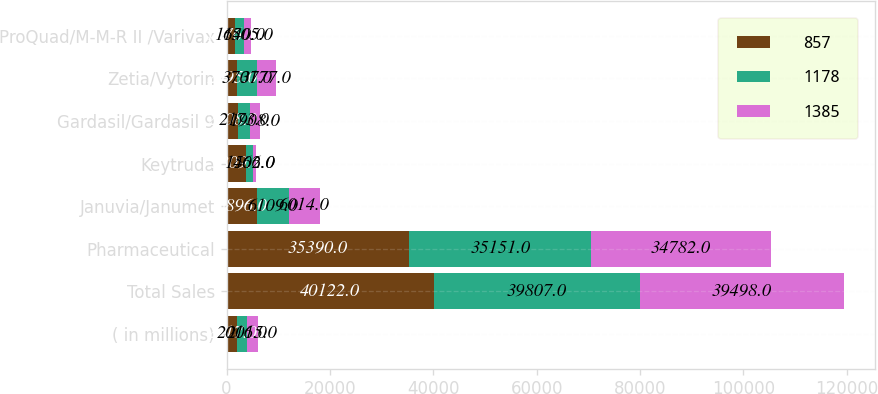Convert chart. <chart><loc_0><loc_0><loc_500><loc_500><stacked_bar_chart><ecel><fcel>( in millions)<fcel>Total Sales<fcel>Pharmaceutical<fcel>Januvia/Janumet<fcel>Keytruda<fcel>Gardasil/Gardasil 9<fcel>Zetia/Vytorin<fcel>ProQuad/M-M-R II /Varivax<nl><fcel>857<fcel>2017<fcel>40122<fcel>35390<fcel>5896<fcel>3809<fcel>2308<fcel>2095<fcel>1676<nl><fcel>1178<fcel>2016<fcel>39807<fcel>35151<fcel>6109<fcel>1402<fcel>2173<fcel>3701<fcel>1640<nl><fcel>1385<fcel>2015<fcel>39498<fcel>34782<fcel>6014<fcel>566<fcel>1908<fcel>3777<fcel>1505<nl></chart> 